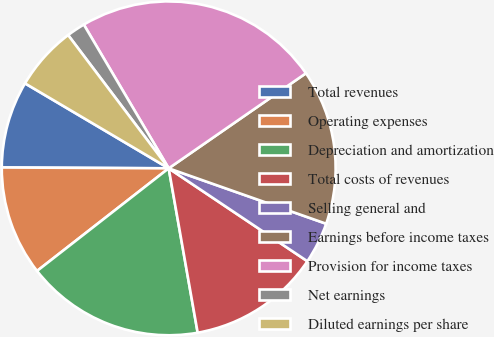Convert chart. <chart><loc_0><loc_0><loc_500><loc_500><pie_chart><fcel>Total revenues<fcel>Operating expenses<fcel>Depreciation and amortization<fcel>Total costs of revenues<fcel>Selling general and<fcel>Earnings before income taxes<fcel>Provision for income taxes<fcel>Net earnings<fcel>Diluted earnings per share<nl><fcel>8.42%<fcel>10.62%<fcel>17.24%<fcel>12.83%<fcel>4.01%<fcel>15.03%<fcel>23.85%<fcel>1.8%<fcel>6.21%<nl></chart> 